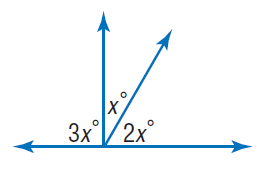Question: Find x.
Choices:
A. 30
B. 60
C. 90
D. 180
Answer with the letter. Answer: A 